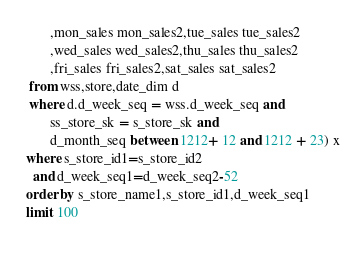<code> <loc_0><loc_0><loc_500><loc_500><_SQL_>        ,mon_sales mon_sales2,tue_sales tue_sales2
        ,wed_sales wed_sales2,thu_sales thu_sales2
        ,fri_sales fri_sales2,sat_sales sat_sales2
  from wss,store,date_dim d
  where d.d_week_seq = wss.d_week_seq and
        ss_store_sk = s_store_sk and
        d_month_seq between 1212+ 12 and 1212 + 23) x
 where s_store_id1=s_store_id2
   and d_week_seq1=d_week_seq2-52
 order by s_store_name1,s_store_id1,d_week_seq1
 limit 100
            
</code> 